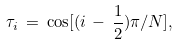<formula> <loc_0><loc_0><loc_500><loc_500>\tau _ { i } \, = \, \cos [ ( i \, - \, { \frac { 1 } { 2 } } ) \pi / N ] ,</formula> 